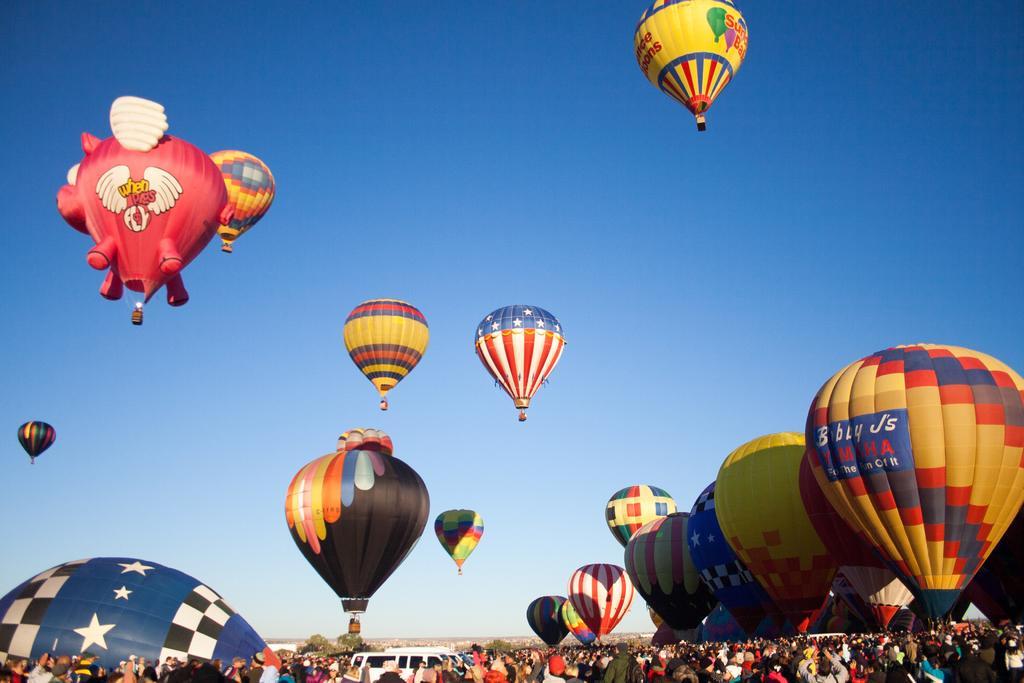Please provide a concise description of this image. There are many people and vehicles at the bottom side of the image and there are hot air balloons and sky in the image. 